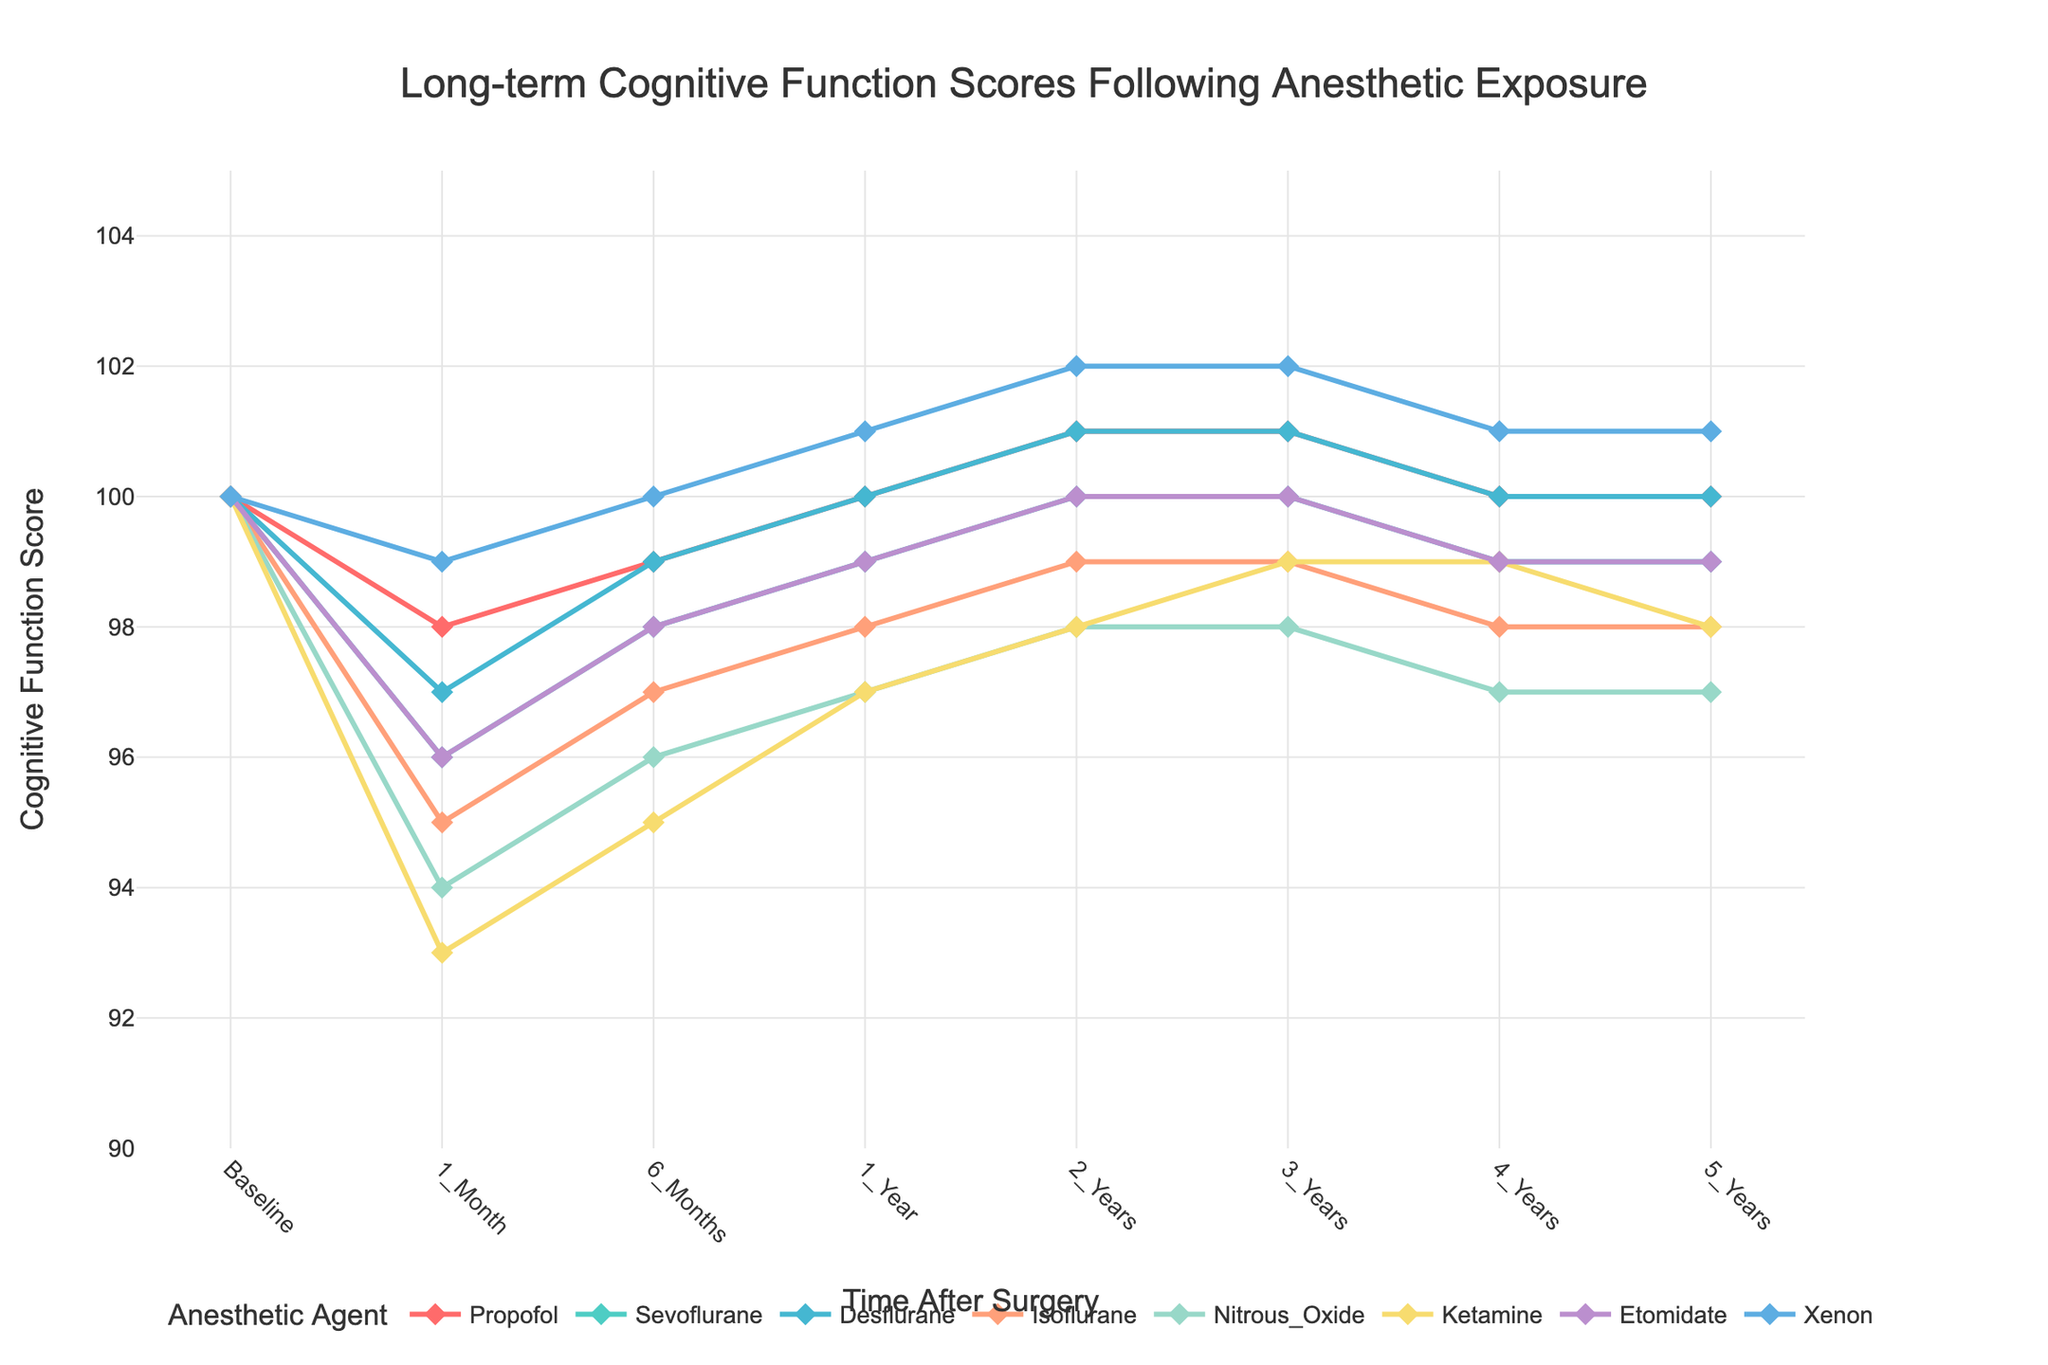What is the average cognitive function score for Propofol at 1 Year and 5 Years post-surgery? To find the average, add the scores at 1 Year (100) and 5 Years (100), then divide by 2. (100 + 100) / 2 = 100
Answer: 100 Which anesthetic agent showed the largest decrease in cognitive function score from Baseline to 1 Month? At Baseline, all agents have a score of 100. The cognitive function scores at 1 Month for each agent are: Propofol (98), Sevoflurane (96), Desflurane (97), Isoflurane (95), Nitrous_Oxide (94), Ketamine (93), Etomidate (96), Xenon (99). The greatest decrease is seen with Ketamine (100 - 93 = 7 points decrease).
Answer: Ketamine Between Desflurane and Isoflurane, which agent shows a higher cognitive function score at 2 Years post-surgery? Compare the scores at 2 Years: Desflurane (101) and Isoflurane (99). Desflurane has a higher score.
Answer: Desflurane At which time point(s) does Xenon show the highest cognitive function score relative to other anesthetic agents? Xenon's score is highest among all agents at 2 Years (102) and 3 Years (102).
Answer: 2 Years, 3 Years How much does the cognitive function score of Ketamine increase from 1 Month to 5 Years post-surgery? Find the scores at 1 Month (93) and 5 Years (98) for Ketamine. Then, compute the difference: 98 - 93 = 5.
Answer: 5 Which anesthetic agent shows no change in cognitive function score from 1 Year to 5 Years post-surgery? Inspect each agent's scores from 1 Year to 5 Years: Propofol (100 to 100), Sevoflurane (100 to 99), Desflurane (100 to 100), Isoflurane (98 to 98), Nitrous_Oxide (97 to 97), Ketamine (97 to 98), Etomidate (99 to 99), Xenon (101 to 101). Both Propofol and Desflurane show no change.
Answer: Propofol, Desflurane What is the median cognitive function score of Isoflurane across all time points? List all scores for Isoflurane: [100, 95, 97, 98, 99, 99, 98, 98]. Arrange in ascending order: [95, 97, 98, 98, 98, 99, 99, 100]. The median is the average of the 4th and 5th values: (98+98)/2 = 98.
Answer: 98 Which anesthetic agent showed the most steady cognitive function score over the 5-year period? A steady cognitive function score means minimal fluctuation. Examining scores: Propofol (100 to 100), Sevoflurane (100 to 99), Desflurane (100 to 100), Isoflurane (100 to 98), Nitrous_Oxide (100 to 97), Ketamine (100 to 98), Etomidate (100 to 99), Xenon (100 to 101). Propofol and Desflurane remain within a range of 2 points.
Answer: Propofol, Desflurane 